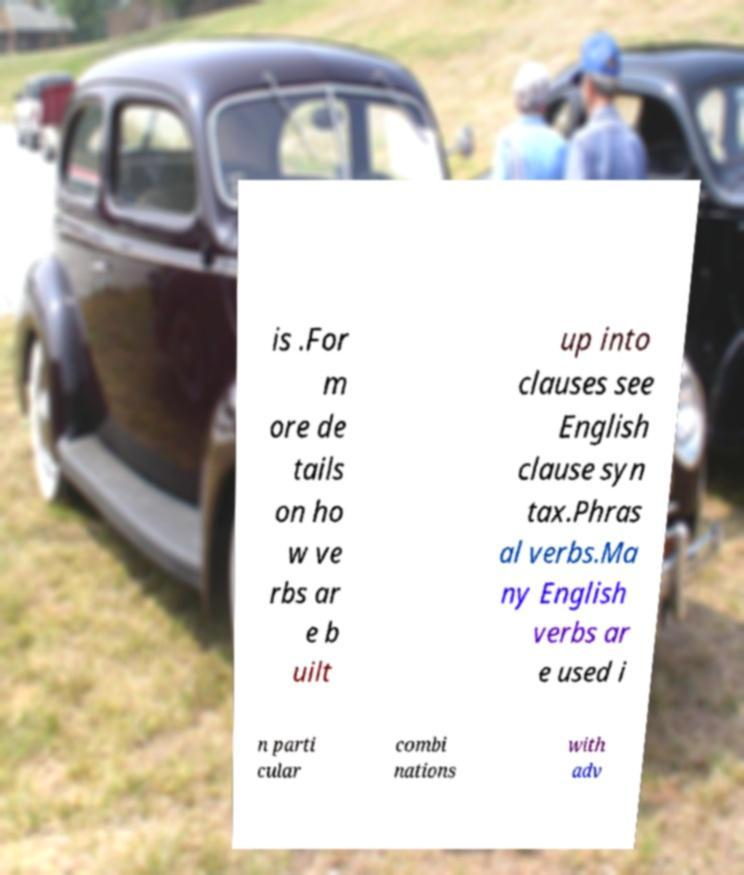Please identify and transcribe the text found in this image. is .For m ore de tails on ho w ve rbs ar e b uilt up into clauses see English clause syn tax.Phras al verbs.Ma ny English verbs ar e used i n parti cular combi nations with adv 